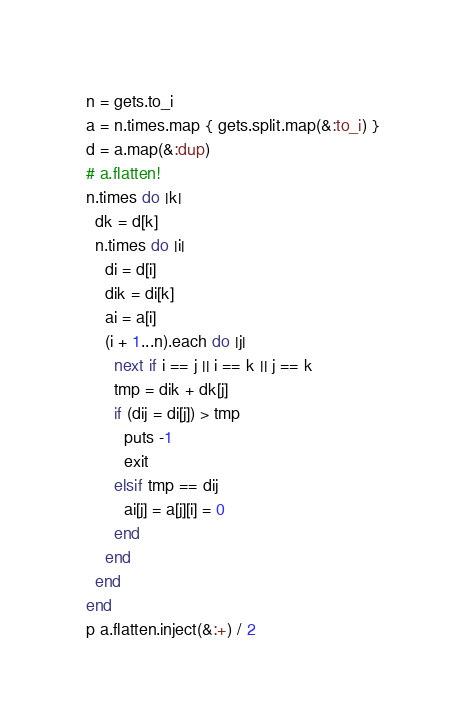Convert code to text. <code><loc_0><loc_0><loc_500><loc_500><_Ruby_>n = gets.to_i
a = n.times.map { gets.split.map(&:to_i) }
d = a.map(&:dup)
# a.flatten!
n.times do |k|
  dk = d[k]
  n.times do |i|
    di = d[i]
    dik = di[k]
    ai = a[i]
    (i + 1...n).each do |j|
      next if i == j || i == k || j == k
      tmp = dik + dk[j]
      if (dij = di[j]) > tmp
        puts -1
        exit
      elsif tmp == dij
        ai[j] = a[j][i] = 0
      end
    end
  end
end
p a.flatten.inject(&:+) / 2
</code> 